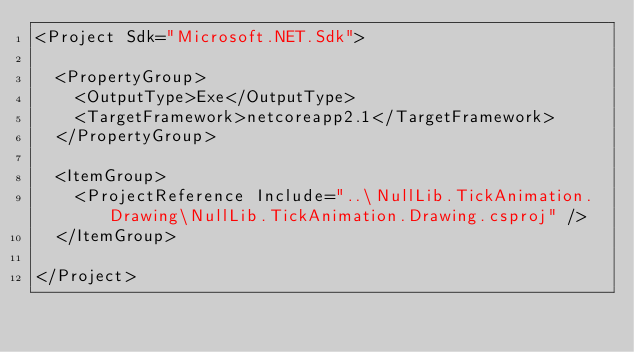Convert code to text. <code><loc_0><loc_0><loc_500><loc_500><_XML_><Project Sdk="Microsoft.NET.Sdk">

  <PropertyGroup>
    <OutputType>Exe</OutputType>
    <TargetFramework>netcoreapp2.1</TargetFramework>
  </PropertyGroup>

  <ItemGroup>
    <ProjectReference Include="..\NullLib.TickAnimation.Drawing\NullLib.TickAnimation.Drawing.csproj" />
  </ItemGroup>

</Project>
</code> 